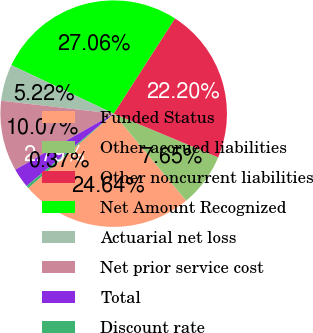Convert chart to OTSL. <chart><loc_0><loc_0><loc_500><loc_500><pie_chart><fcel>Funded Status<fcel>Other accrued liabilities<fcel>Other noncurrent liabilities<fcel>Net Amount Recognized<fcel>Actuarial net loss<fcel>Net prior service cost<fcel>Total<fcel>Discount rate<nl><fcel>24.64%<fcel>7.65%<fcel>22.2%<fcel>27.06%<fcel>5.22%<fcel>10.07%<fcel>2.79%<fcel>0.37%<nl></chart> 